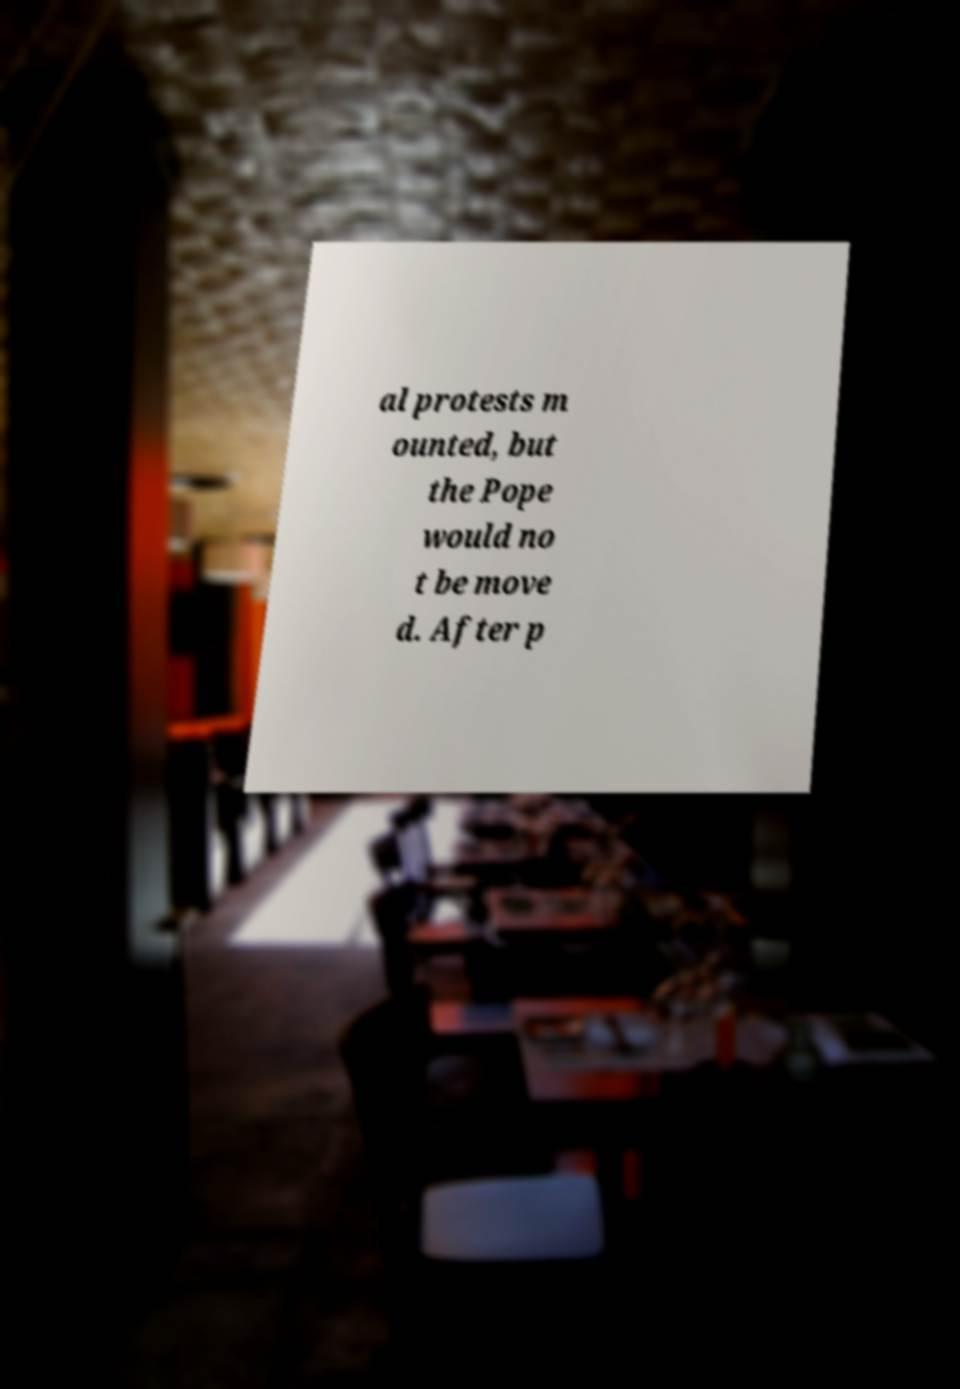Could you assist in decoding the text presented in this image and type it out clearly? al protests m ounted, but the Pope would no t be move d. After p 